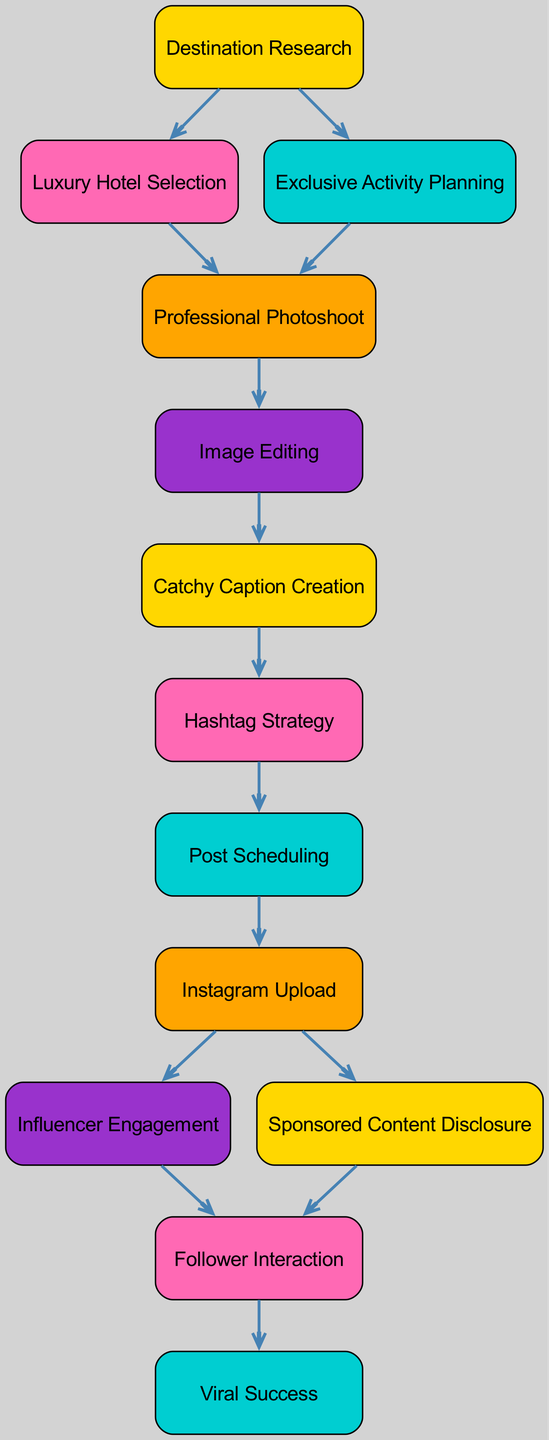What is the first step in the luxury travel post journey? The first step in the journey is "Destination Research," which starts the process of creating a luxury travel post. It is depicted as the initial node in the diagram.
Answer: Destination Research How many nodes are in the diagram? By counting the listed nodes, there are a total of 13 unique nodes that represent different stages of the journey in creating a luxurious travel post.
Answer: 13 What is the last step leading to viral success? The last step before achieving viral success is "Follower Interaction," where the engagement with followers happens. This step is positioned just before the final outcome in the diagram.
Answer: Follower Interaction Which node comes after "Image Editing"? The node that comes after "Image Editing" is "Catchy Caption Creation," indicating that after editing the photos, the next task is to create a catchy caption for the post.
Answer: Catchy Caption Creation What are the two steps that follow "Instagram Upload"? After "Instagram Upload," the two subsequent steps are "Influencer Engagement" and "Sponsored Content Disclosure," reflecting the marketing activities post-upload.
Answer: Influencer Engagement and Sponsored Content Disclosure Which two nodes are connected to "Follower Interaction"? "Follower Interaction" is connected to two preceding nodes, which are "Influencer Engagement" and "Sponsored Content Disclosure." These connections indicate that both prior actions lead to this engagement step.
Answer: Influencer Engagement and Sponsored Content Disclosure Which two aspects are prioritized after "Catchy Caption Creation"? After "Catchy Caption Creation," the priorities shift to "Hashtag Strategy" followed by "Post Scheduling," showing that these elements are essential for promoting the post effectively.
Answer: Hashtag Strategy and Post Scheduling What is the relationship between "Exclusive Activity Planning" and "Professional Photoshoot"? The relationship is that "Exclusive Activity Planning" leads to "Professional Photoshoot," meaning that planning activities specifically influences what will be photographed professionally.
Answer: Exclusive Activity Planning leads to Professional Photoshoot 